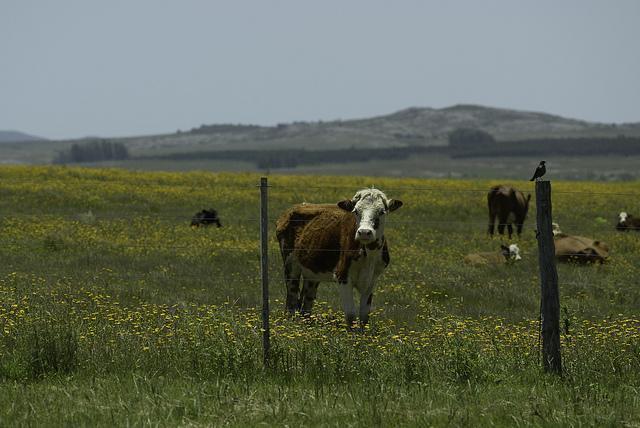How many cows are in the picture?
Give a very brief answer. 6. How many people are holding a bat?
Give a very brief answer. 0. 